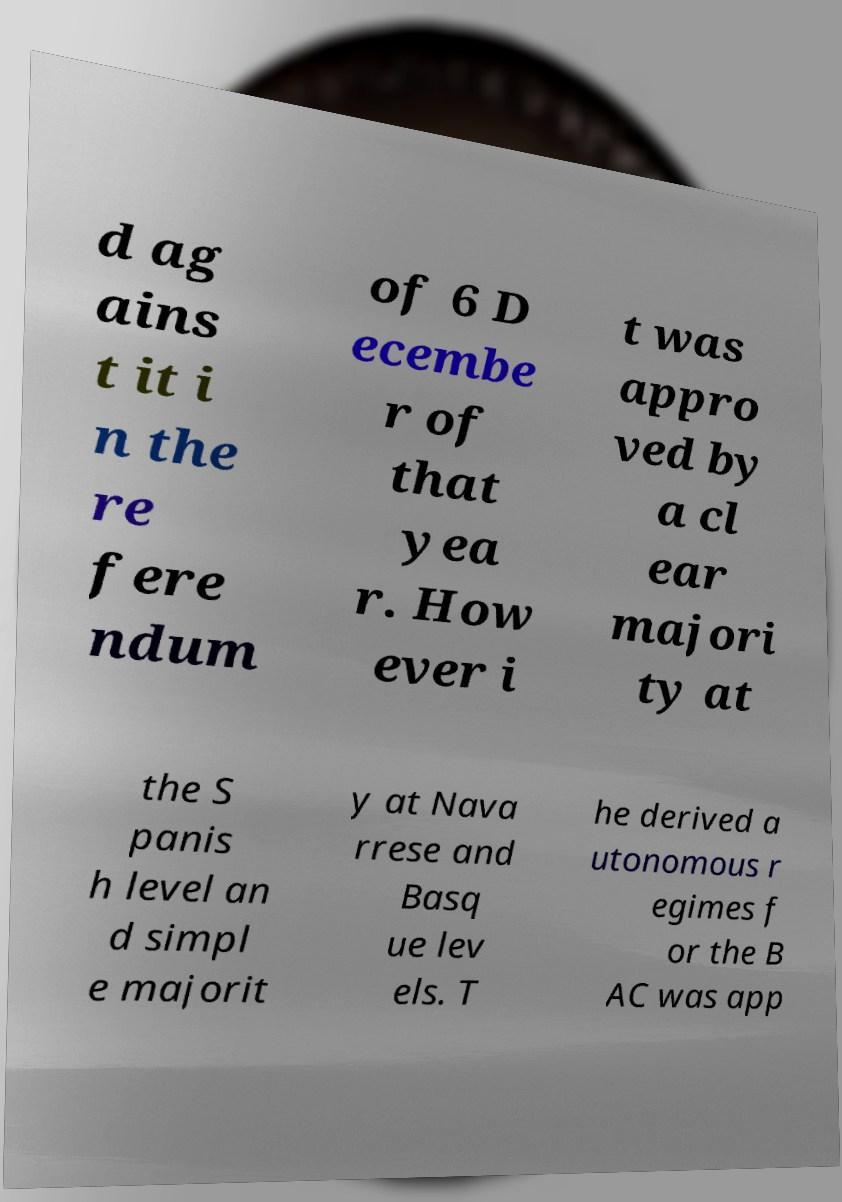I need the written content from this picture converted into text. Can you do that? d ag ains t it i n the re fere ndum of 6 D ecembe r of that yea r. How ever i t was appro ved by a cl ear majori ty at the S panis h level an d simpl e majorit y at Nava rrese and Basq ue lev els. T he derived a utonomous r egimes f or the B AC was app 